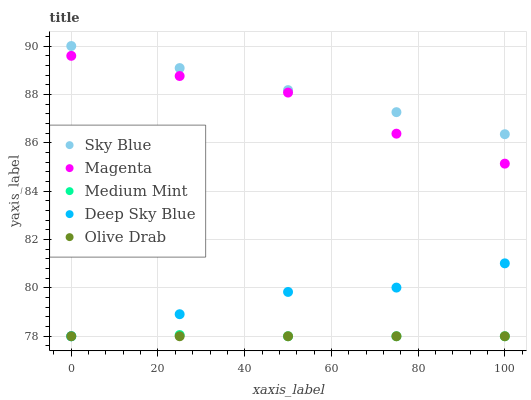Does Olive Drab have the minimum area under the curve?
Answer yes or no. Yes. Does Sky Blue have the maximum area under the curve?
Answer yes or no. Yes. Does Magenta have the minimum area under the curve?
Answer yes or no. No. Does Magenta have the maximum area under the curve?
Answer yes or no. No. Is Olive Drab the smoothest?
Answer yes or no. Yes. Is Magenta the roughest?
Answer yes or no. Yes. Is Sky Blue the smoothest?
Answer yes or no. No. Is Sky Blue the roughest?
Answer yes or no. No. Does Medium Mint have the lowest value?
Answer yes or no. Yes. Does Magenta have the lowest value?
Answer yes or no. No. Does Sky Blue have the highest value?
Answer yes or no. Yes. Does Magenta have the highest value?
Answer yes or no. No. Is Medium Mint less than Magenta?
Answer yes or no. Yes. Is Sky Blue greater than Medium Mint?
Answer yes or no. Yes. Does Medium Mint intersect Olive Drab?
Answer yes or no. Yes. Is Medium Mint less than Olive Drab?
Answer yes or no. No. Is Medium Mint greater than Olive Drab?
Answer yes or no. No. Does Medium Mint intersect Magenta?
Answer yes or no. No. 